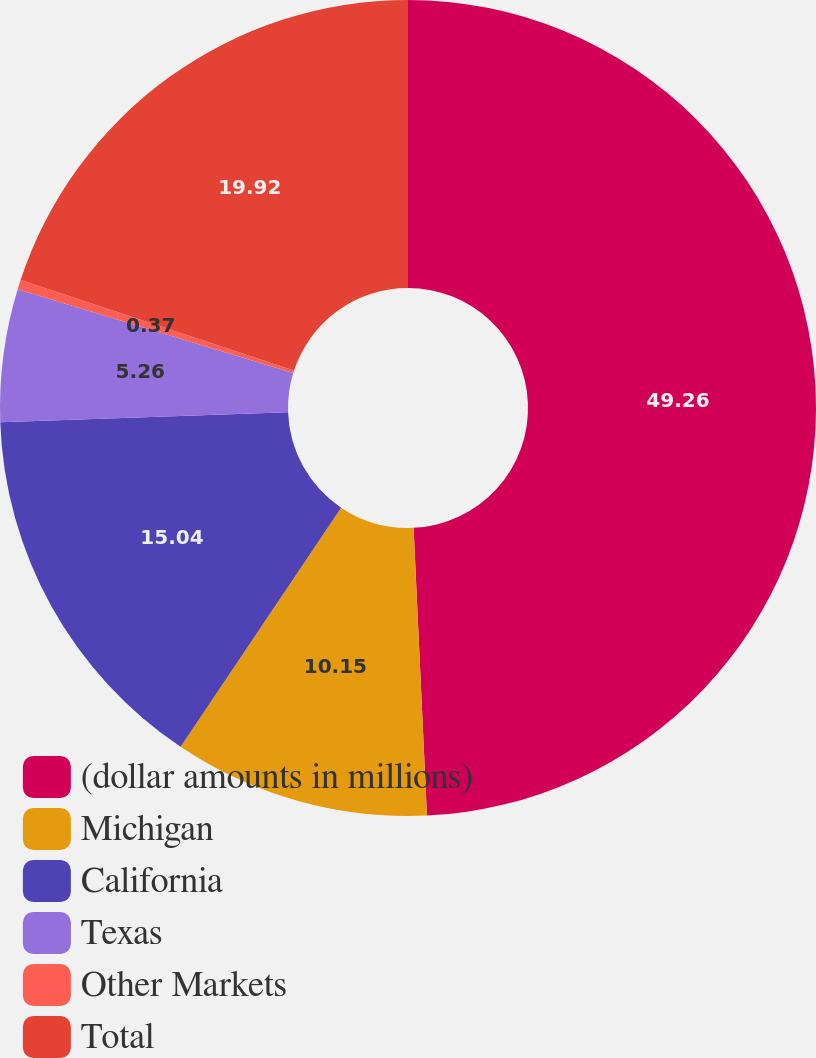Convert chart. <chart><loc_0><loc_0><loc_500><loc_500><pie_chart><fcel>(dollar amounts in millions)<fcel>Michigan<fcel>California<fcel>Texas<fcel>Other Markets<fcel>Total<nl><fcel>49.27%<fcel>10.15%<fcel>15.04%<fcel>5.26%<fcel>0.37%<fcel>19.93%<nl></chart> 